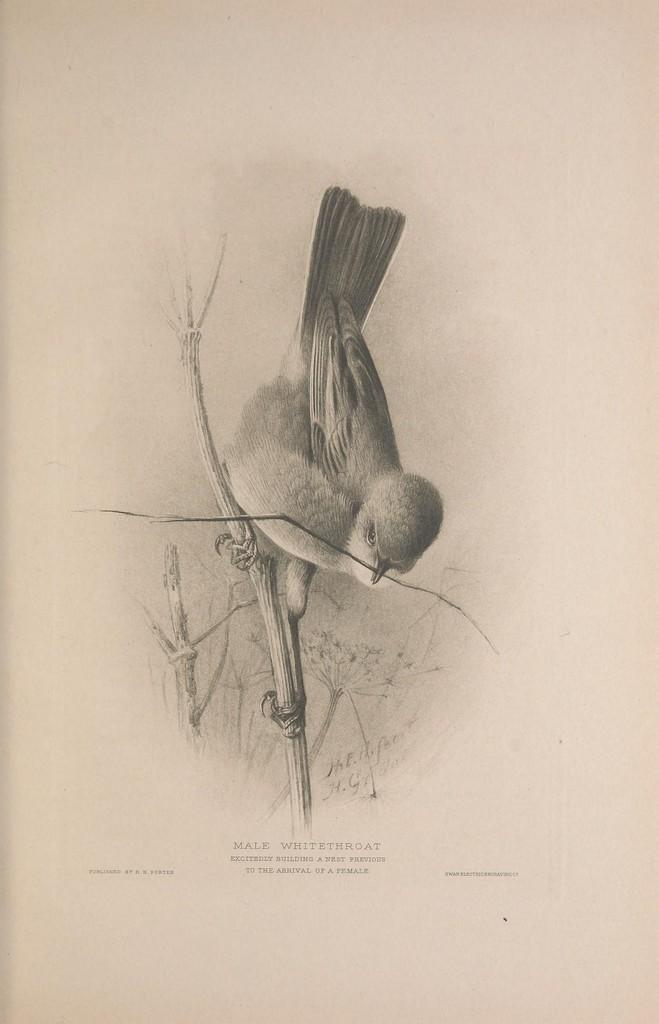What is depicted in the image? There is a sketch drawing of a bird in the image. Can you describe the bird's position in the drawing? The bird is standing on a stem in the drawing. What type of polish is the bird using to shine its feathers in the image? There is no polish or indication of the bird using any polish in the image. 